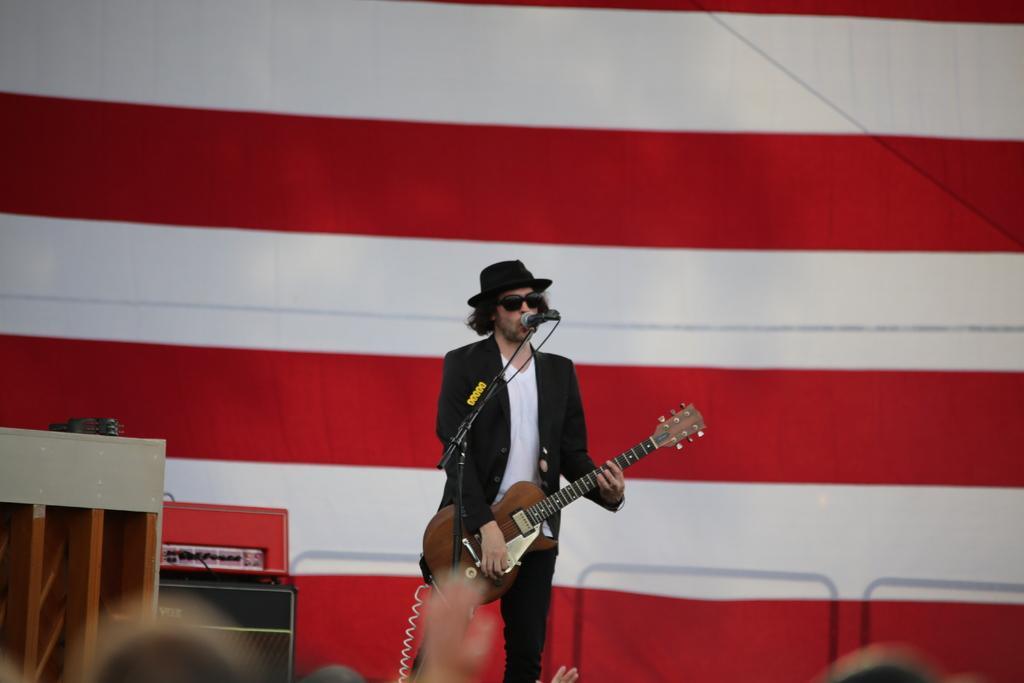Describe this image in one or two sentences. In this picture we can see a man who is standing in front of mike. He is playing guitar and he has goggles. On the background there is a cloth and this is table. 